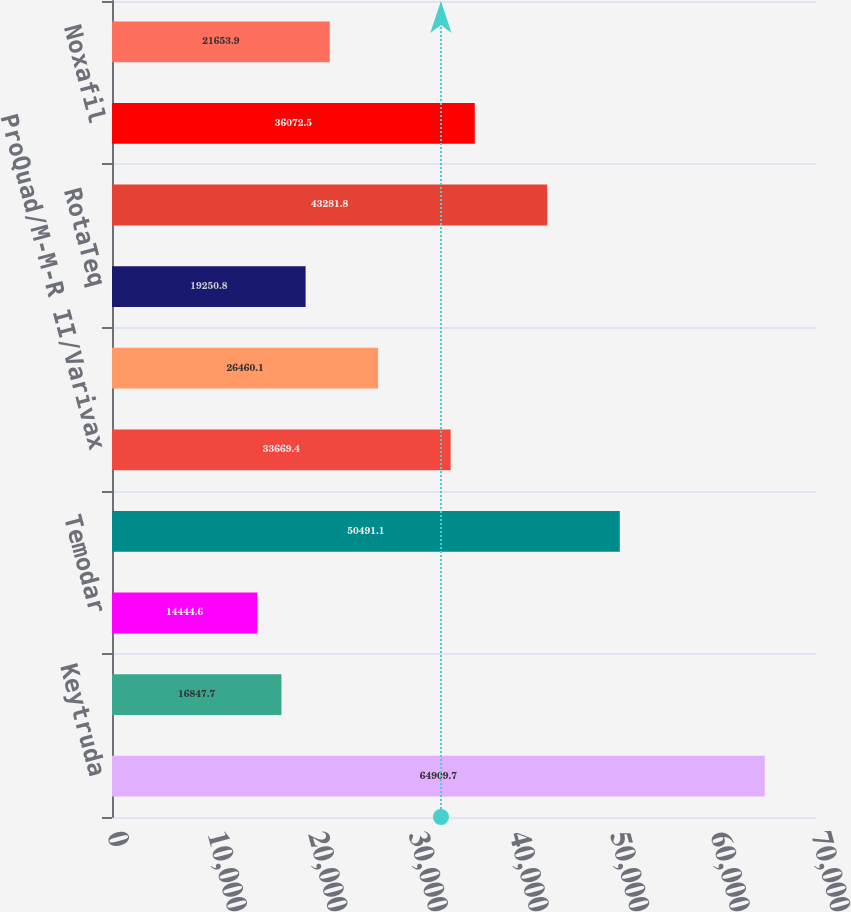Convert chart to OTSL. <chart><loc_0><loc_0><loc_500><loc_500><bar_chart><fcel>Keytruda<fcel>Emend<fcel>Temodar<fcel>Gardasil/Gardasil 9<fcel>ProQuad/M-M-R II/Varivax<fcel>Pneumovax 23<fcel>RotaTeq<fcel>Bridion<fcel>Noxafil<fcel>Invanz<nl><fcel>64909.7<fcel>16847.7<fcel>14444.6<fcel>50491.1<fcel>33669.4<fcel>26460.1<fcel>19250.8<fcel>43281.8<fcel>36072.5<fcel>21653.9<nl></chart> 